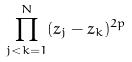Convert formula to latex. <formula><loc_0><loc_0><loc_500><loc_500>\prod _ { j < k = 1 } ^ { N } ( z _ { j } - z _ { k } ) ^ { 2 p }</formula> 